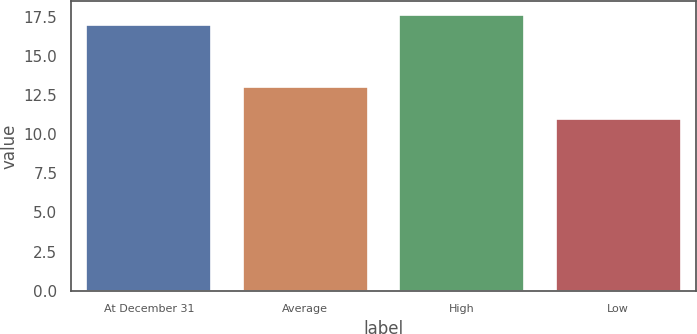Convert chart to OTSL. <chart><loc_0><loc_0><loc_500><loc_500><bar_chart><fcel>At December 31<fcel>Average<fcel>High<fcel>Low<nl><fcel>17<fcel>13<fcel>17.6<fcel>11<nl></chart> 